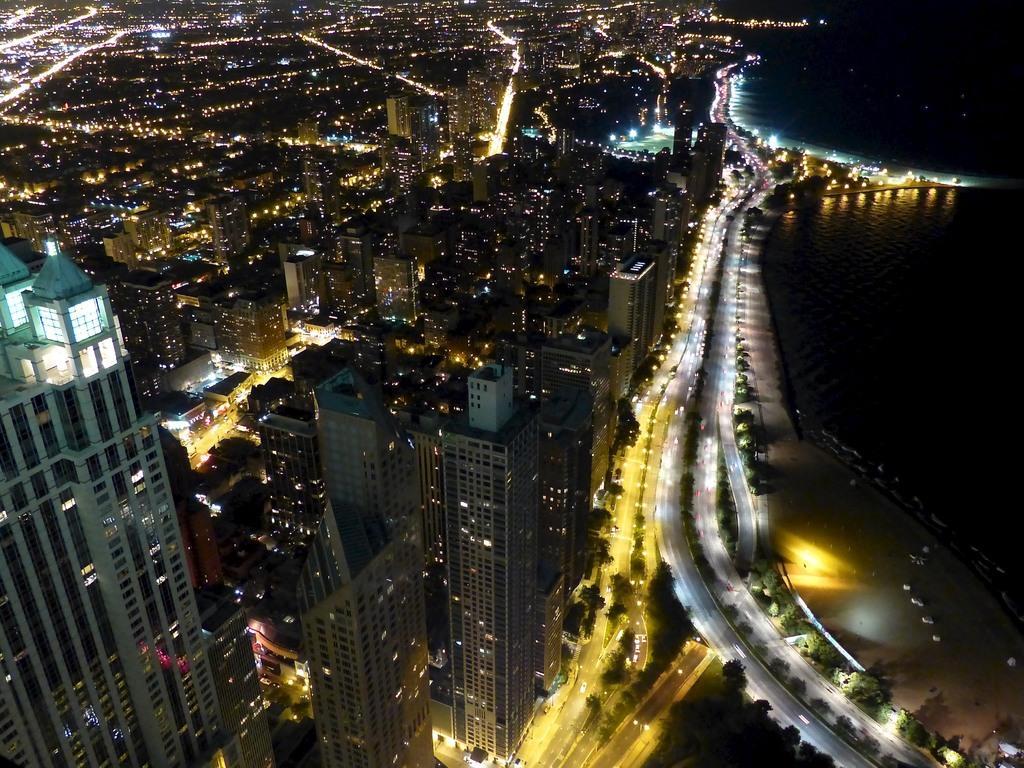Please provide a concise description of this image. In this image there are buildings and there are lights, there are vehicles and on the right side there is water, there are trees. 